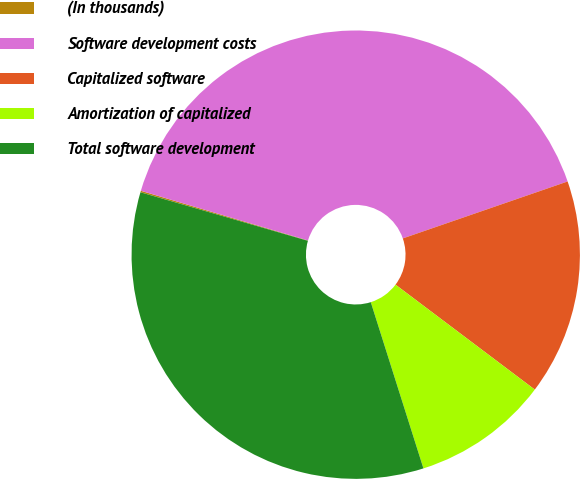Convert chart to OTSL. <chart><loc_0><loc_0><loc_500><loc_500><pie_chart><fcel>(In thousands)<fcel>Software development costs<fcel>Capitalized software<fcel>Amortization of capitalized<fcel>Total software development<nl><fcel>0.11%<fcel>40.1%<fcel>15.57%<fcel>9.84%<fcel>34.37%<nl></chart> 